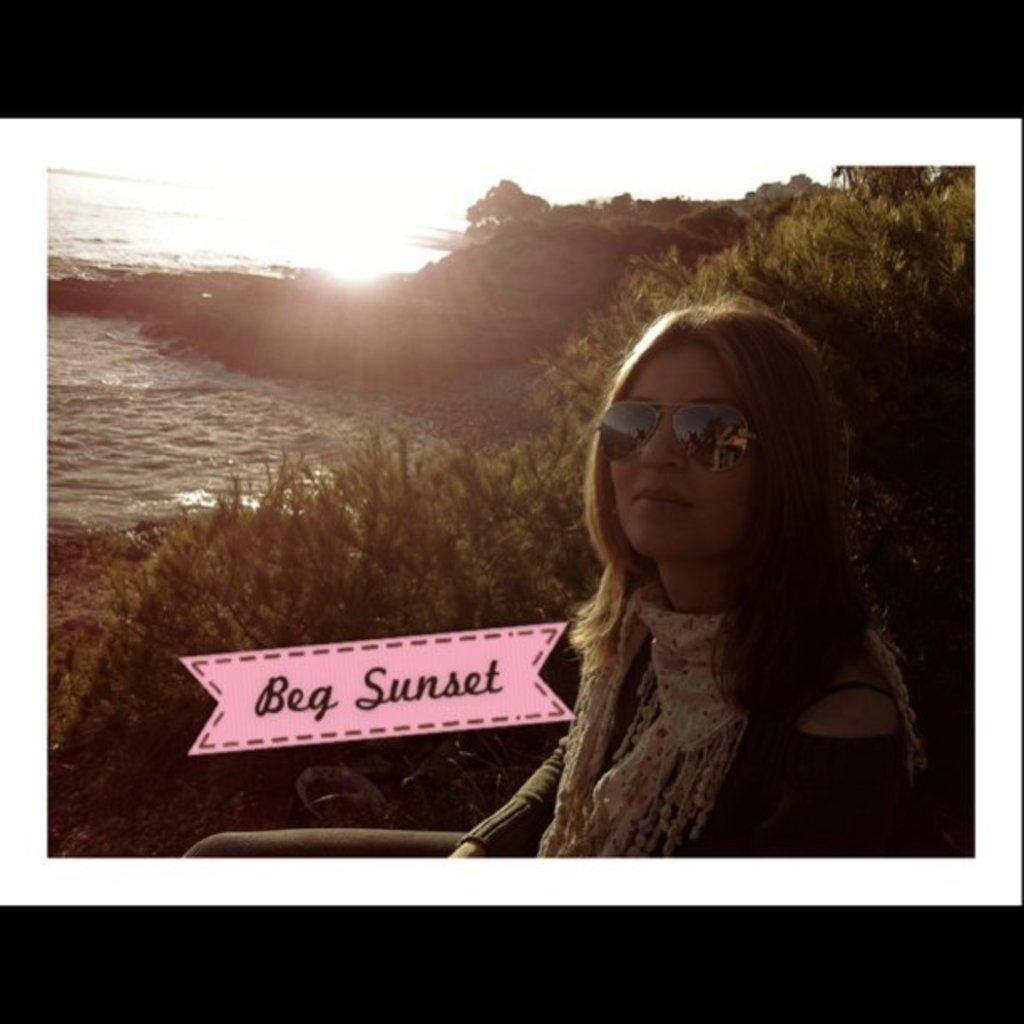Who is the main subject in the image? There is a girl in the image. Where is the girl located in the image? The girl is on the right side of the image. What can be seen on the left side of the image? There is water on the left side of the image. What type of vegetation is on the right side of the image? There are plants on the right side of the image. What type of advertisement can be seen on the girl's shirt in the image? There is no advertisement visible on the girl's shirt in the image. Can you tell me how many keys are hanging from the carriage in the image? There is no carriage or keys present in the image. 